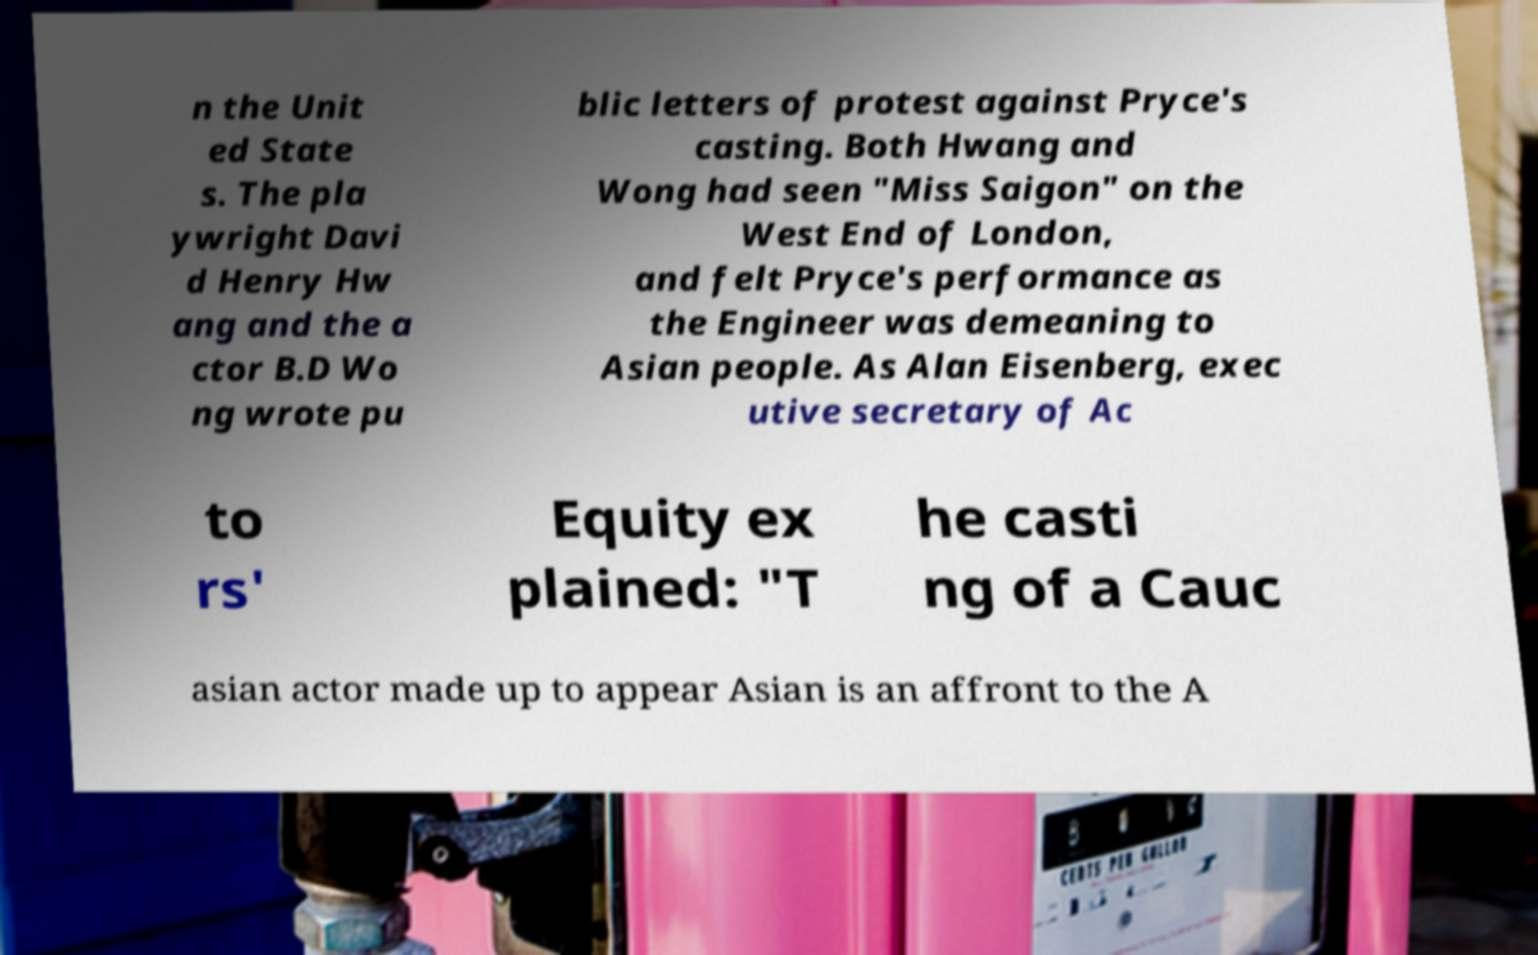Could you assist in decoding the text presented in this image and type it out clearly? n the Unit ed State s. The pla ywright Davi d Henry Hw ang and the a ctor B.D Wo ng wrote pu blic letters of protest against Pryce's casting. Both Hwang and Wong had seen "Miss Saigon" on the West End of London, and felt Pryce's performance as the Engineer was demeaning to Asian people. As Alan Eisenberg, exec utive secretary of Ac to rs' Equity ex plained: "T he casti ng of a Cauc asian actor made up to appear Asian is an affront to the A 